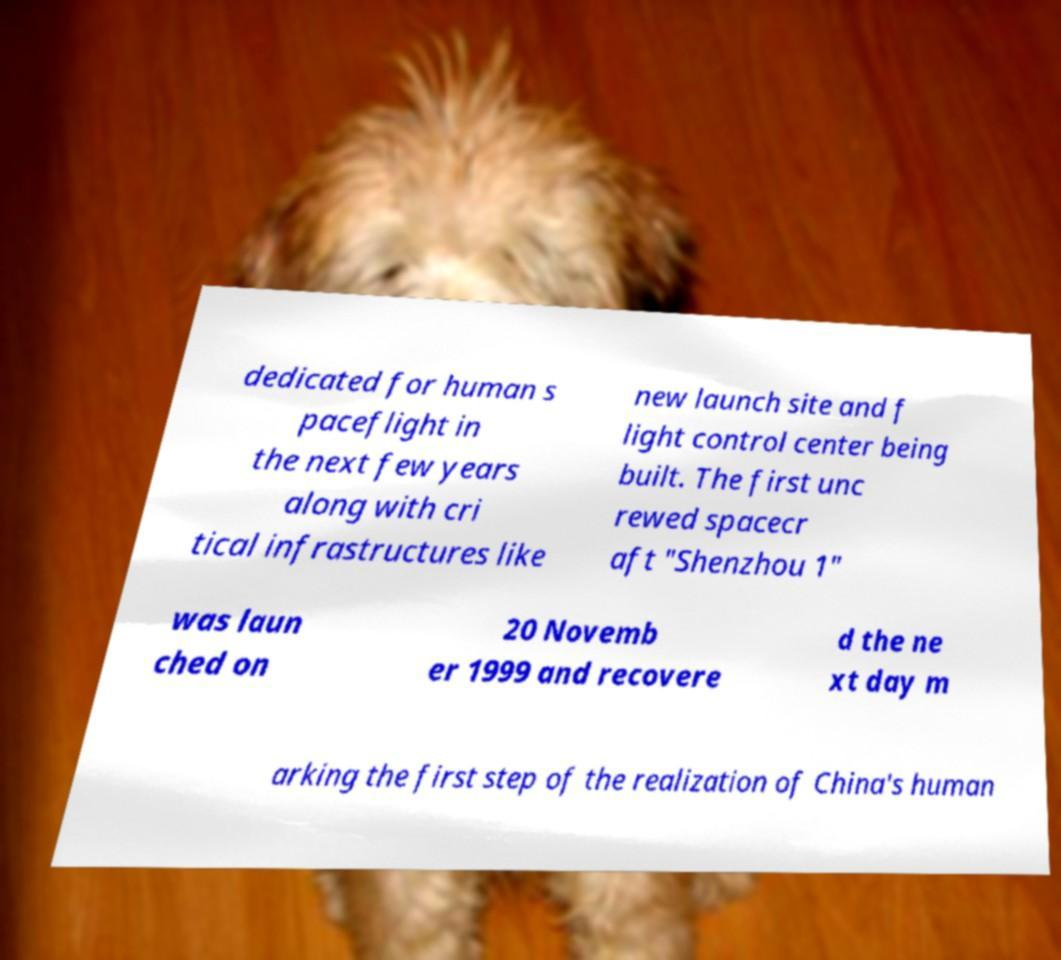Can you accurately transcribe the text from the provided image for me? dedicated for human s paceflight in the next few years along with cri tical infrastructures like new launch site and f light control center being built. The first unc rewed spacecr aft "Shenzhou 1" was laun ched on 20 Novemb er 1999 and recovere d the ne xt day m arking the first step of the realization of China's human 